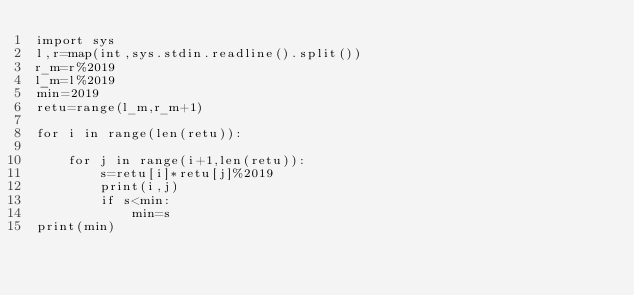Convert code to text. <code><loc_0><loc_0><loc_500><loc_500><_Python_>import sys
l,r=map(int,sys.stdin.readline().split())
r_m=r%2019
l_m=l%2019
min=2019
retu=range(l_m,r_m+1)

for i in range(len(retu)):

    for j in range(i+1,len(retu)):
        s=retu[i]*retu[j]%2019
        print(i,j)
        if s<min:
            min=s
print(min)
</code> 